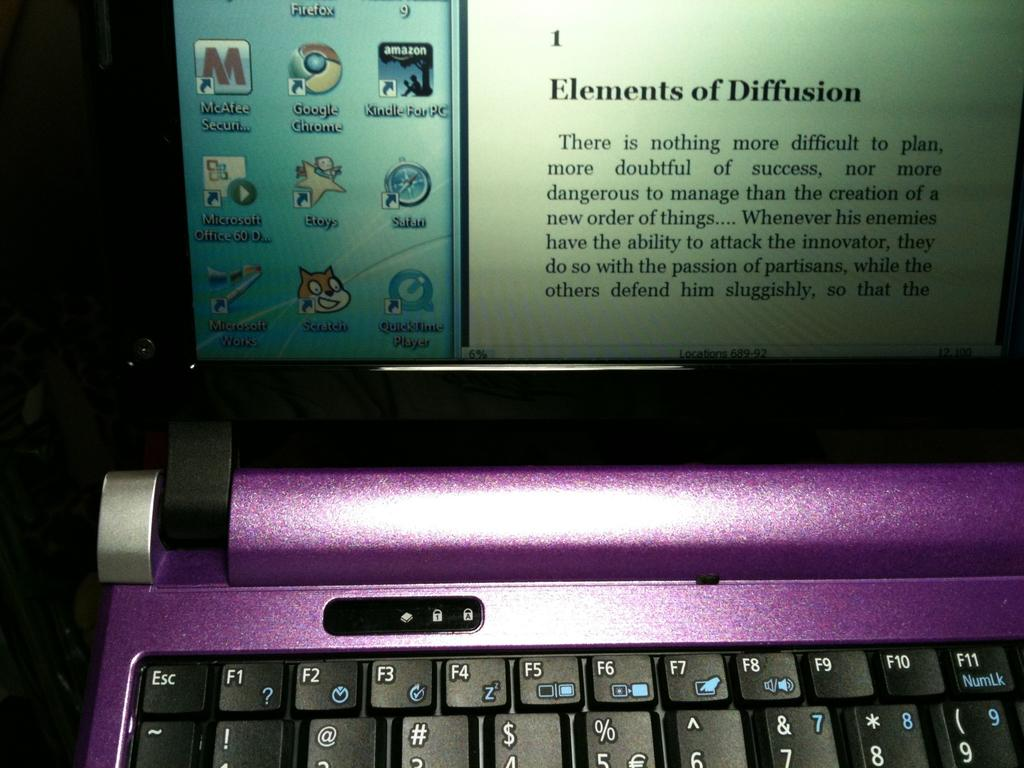<image>
Offer a succinct explanation of the picture presented. A purple laptop with the monitor displaying a paragraph titled Elements of Diffusion 